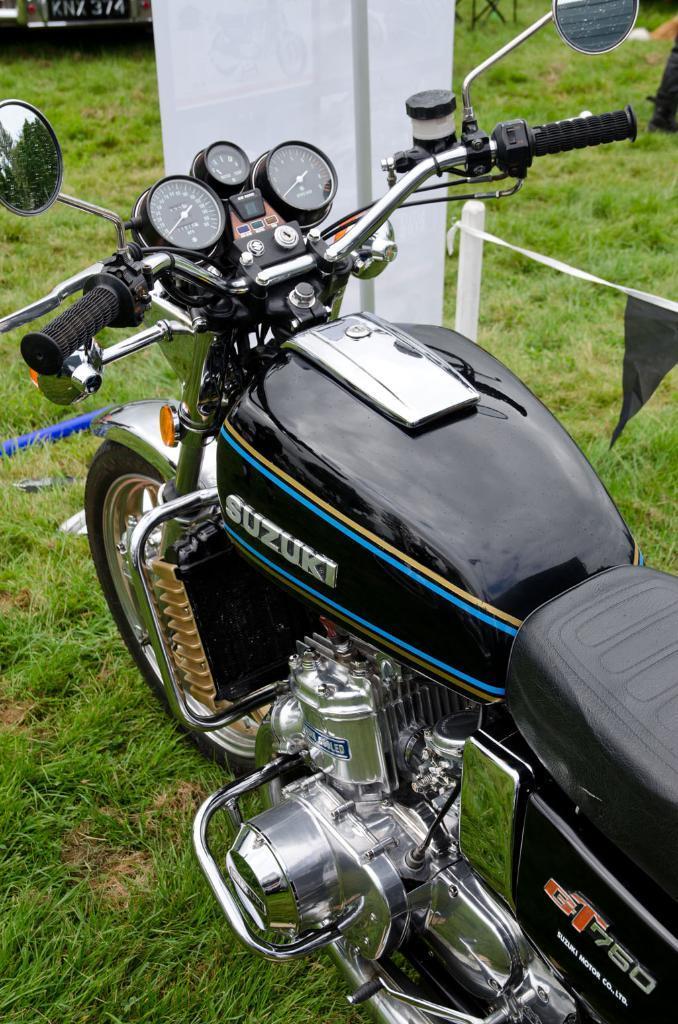In one or two sentences, can you explain what this image depicts? In this image there is a bike on surface of the grass. At front there is a banner. 